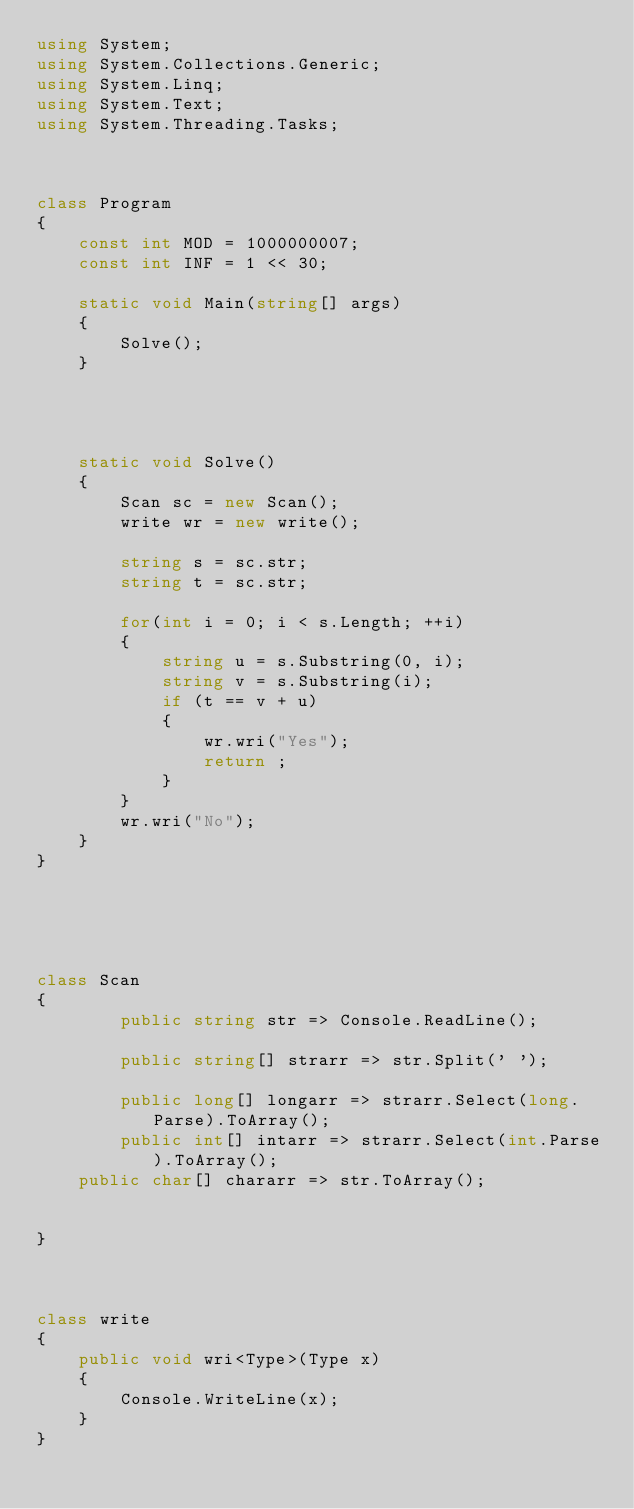Convert code to text. <code><loc_0><loc_0><loc_500><loc_500><_C#_>using System;
using System.Collections.Generic;
using System.Linq;
using System.Text;
using System.Threading.Tasks;



class Program
{
    const int MOD = 1000000007;
    const int INF = 1 << 30;

    static void Main(string[] args)
    {
        Solve();
    }




    static void Solve()
    {
        Scan sc = new Scan();
        write wr = new write();

        string s = sc.str;
        string t = sc.str;

        for(int i = 0; i < s.Length; ++i)
        {
            string u = s.Substring(0, i);
            string v = s.Substring(i);
            if (t == v + u)
            {
                wr.wri("Yes");
                return ;
            }
        }
        wr.wri("No");
    }
}
    




class Scan
{
        public string str => Console.ReadLine();

        public string[] strarr => str.Split(' ');

        public long[] longarr => strarr.Select(long.Parse).ToArray();
        public int[] intarr => strarr.Select(int.Parse).ToArray();
    public char[] chararr => str.ToArray();


}



class write
{
    public void wri<Type>(Type x)
    {
        Console.WriteLine(x);
    }
}
</code> 